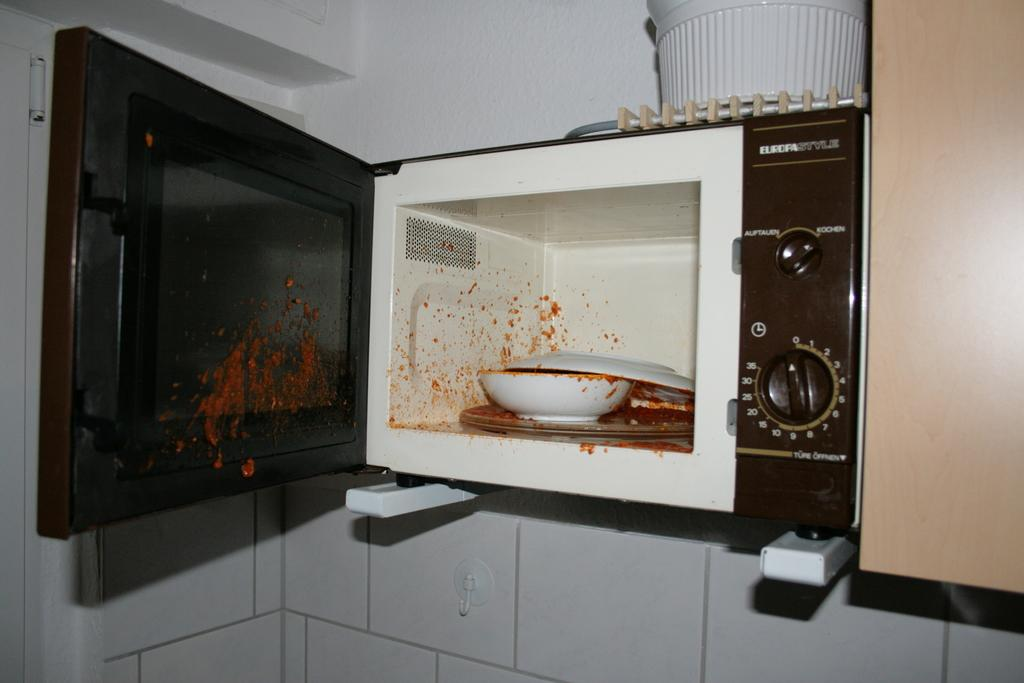What is inside the microwave oven in the image? There is a bowl and plates inside the microwave oven in the image. Can you describe the object on top of the microwave oven? Unfortunately, the image does not provide enough detail to describe the object on top of the microwave oven. What type of zinc is being used to make the bells in the image? There are no bells or zinc present in the image. 